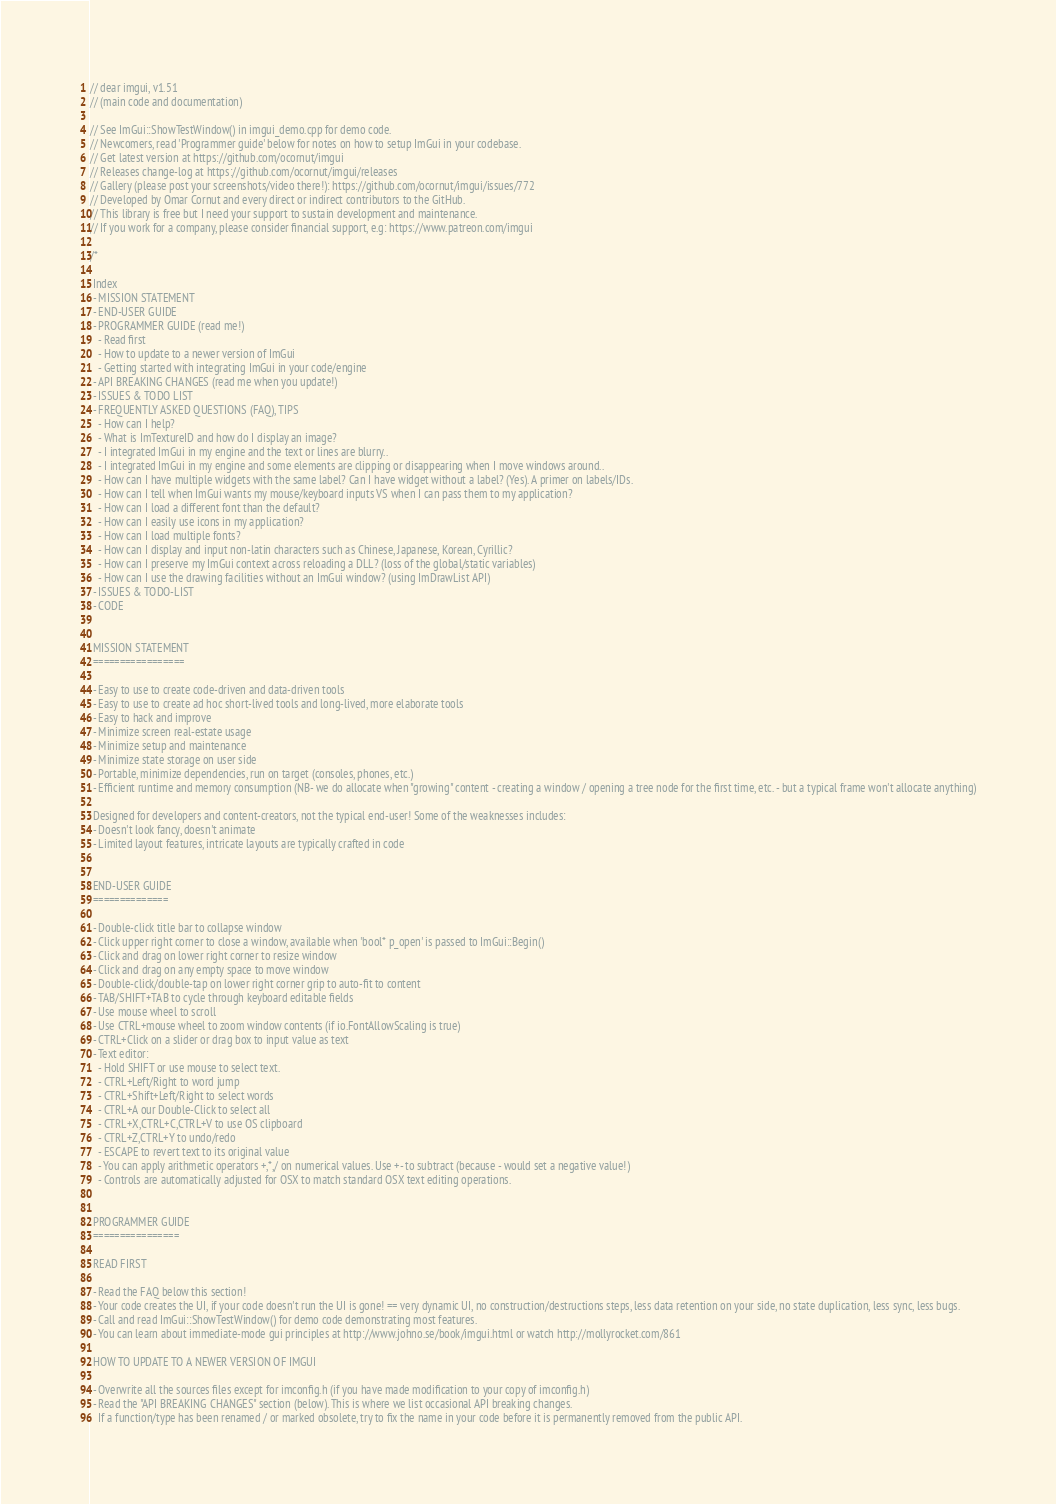Convert code to text. <code><loc_0><loc_0><loc_500><loc_500><_C++_>// dear imgui, v1.51
// (main code and documentation)

// See ImGui::ShowTestWindow() in imgui_demo.cpp for demo code.
// Newcomers, read 'Programmer guide' below for notes on how to setup ImGui in your codebase.
// Get latest version at https://github.com/ocornut/imgui
// Releases change-log at https://github.com/ocornut/imgui/releases
// Gallery (please post your screenshots/video there!): https://github.com/ocornut/imgui/issues/772
// Developed by Omar Cornut and every direct or indirect contributors to the GitHub.
// This library is free but I need your support to sustain development and maintenance.
// If you work for a company, please consider financial support, e.g: https://www.patreon.com/imgui

/*

 Index
 - MISSION STATEMENT
 - END-USER GUIDE
 - PROGRAMMER GUIDE (read me!)
   - Read first
   - How to update to a newer version of ImGui
   - Getting started with integrating ImGui in your code/engine
 - API BREAKING CHANGES (read me when you update!)
 - ISSUES & TODO LIST
 - FREQUENTLY ASKED QUESTIONS (FAQ), TIPS
   - How can I help?
   - What is ImTextureID and how do I display an image?
   - I integrated ImGui in my engine and the text or lines are blurry..
   - I integrated ImGui in my engine and some elements are clipping or disappearing when I move windows around..
   - How can I have multiple widgets with the same label? Can I have widget without a label? (Yes). A primer on labels/IDs.
   - How can I tell when ImGui wants my mouse/keyboard inputs VS when I can pass them to my application?
   - How can I load a different font than the default?
   - How can I easily use icons in my application?
   - How can I load multiple fonts?
   - How can I display and input non-latin characters such as Chinese, Japanese, Korean, Cyrillic?
   - How can I preserve my ImGui context across reloading a DLL? (loss of the global/static variables)
   - How can I use the drawing facilities without an ImGui window? (using ImDrawList API)
 - ISSUES & TODO-LIST
 - CODE


 MISSION STATEMENT
 =================

 - Easy to use to create code-driven and data-driven tools
 - Easy to use to create ad hoc short-lived tools and long-lived, more elaborate tools
 - Easy to hack and improve
 - Minimize screen real-estate usage
 - Minimize setup and maintenance
 - Minimize state storage on user side
 - Portable, minimize dependencies, run on target (consoles, phones, etc.)
 - Efficient runtime and memory consumption (NB- we do allocate when "growing" content - creating a window / opening a tree node for the first time, etc. - but a typical frame won't allocate anything)

 Designed for developers and content-creators, not the typical end-user! Some of the weaknesses includes:
 - Doesn't look fancy, doesn't animate
 - Limited layout features, intricate layouts are typically crafted in code


 END-USER GUIDE
 ==============

 - Double-click title bar to collapse window
 - Click upper right corner to close a window, available when 'bool* p_open' is passed to ImGui::Begin()
 - Click and drag on lower right corner to resize window
 - Click and drag on any empty space to move window
 - Double-click/double-tap on lower right corner grip to auto-fit to content
 - TAB/SHIFT+TAB to cycle through keyboard editable fields
 - Use mouse wheel to scroll
 - Use CTRL+mouse wheel to zoom window contents (if io.FontAllowScaling is true)
 - CTRL+Click on a slider or drag box to input value as text
 - Text editor:
   - Hold SHIFT or use mouse to select text.
   - CTRL+Left/Right to word jump
   - CTRL+Shift+Left/Right to select words
   - CTRL+A our Double-Click to select all
   - CTRL+X,CTRL+C,CTRL+V to use OS clipboard
   - CTRL+Z,CTRL+Y to undo/redo
   - ESCAPE to revert text to its original value
   - You can apply arithmetic operators +,*,/ on numerical values. Use +- to subtract (because - would set a negative value!)
   - Controls are automatically adjusted for OSX to match standard OSX text editing operations.


 PROGRAMMER GUIDE
 ================

 READ FIRST

 - Read the FAQ below this section!
 - Your code creates the UI, if your code doesn't run the UI is gone! == very dynamic UI, no construction/destructions steps, less data retention on your side, no state duplication, less sync, less bugs.
 - Call and read ImGui::ShowTestWindow() for demo code demonstrating most features.
 - You can learn about immediate-mode gui principles at http://www.johno.se/book/imgui.html or watch http://mollyrocket.com/861

 HOW TO UPDATE TO A NEWER VERSION OF IMGUI

 - Overwrite all the sources files except for imconfig.h (if you have made modification to your copy of imconfig.h)
 - Read the "API BREAKING CHANGES" section (below). This is where we list occasional API breaking changes. 
   If a function/type has been renamed / or marked obsolete, try to fix the name in your code before it is permanently removed from the public API.</code> 